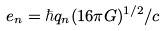<formula> <loc_0><loc_0><loc_500><loc_500>e _ { n } = \hbar { q } _ { n } ( 1 6 \pi G ) ^ { 1 / 2 } / c</formula> 